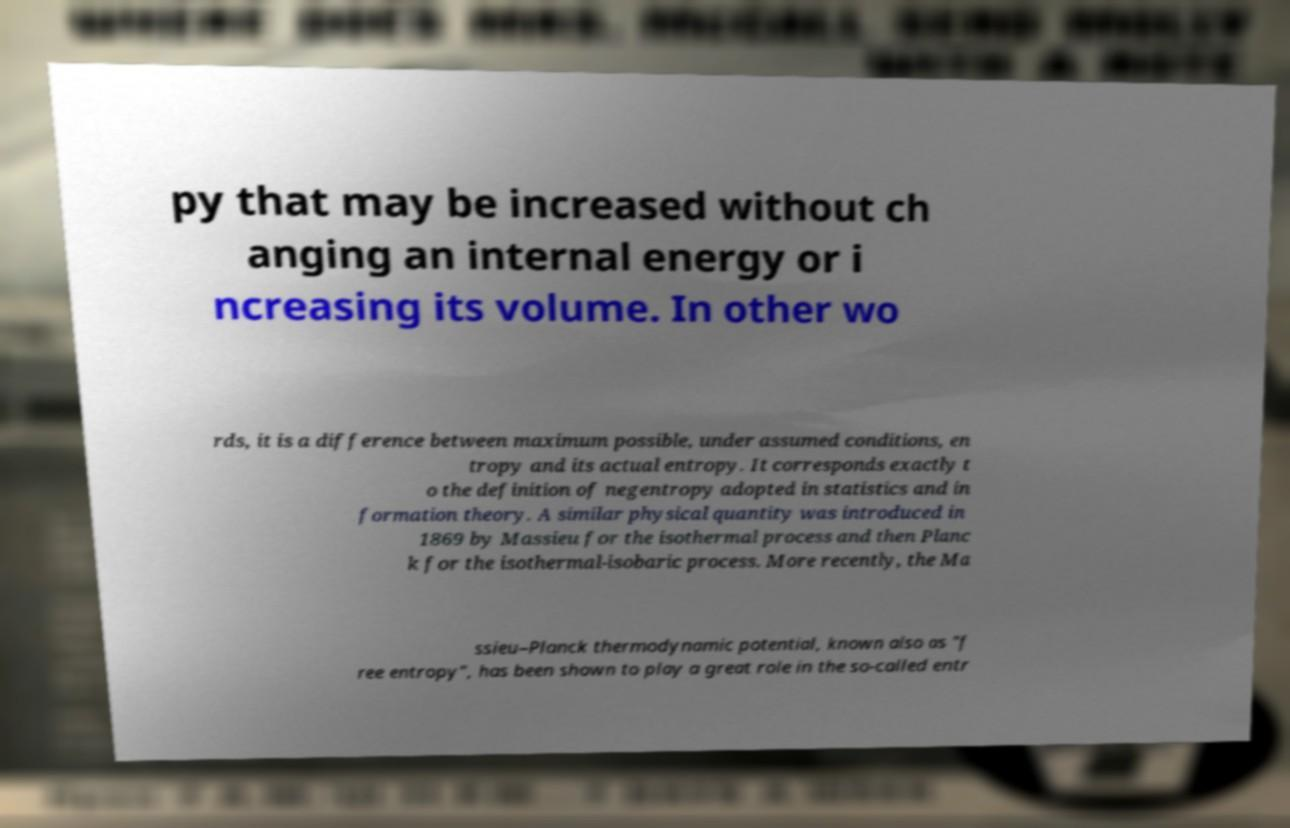Could you extract and type out the text from this image? py that may be increased without ch anging an internal energy or i ncreasing its volume. In other wo rds, it is a difference between maximum possible, under assumed conditions, en tropy and its actual entropy. It corresponds exactly t o the definition of negentropy adopted in statistics and in formation theory. A similar physical quantity was introduced in 1869 by Massieu for the isothermal process and then Planc k for the isothermal-isobaric process. More recently, the Ma ssieu–Planck thermodynamic potential, known also as "f ree entropy", has been shown to play a great role in the so-called entr 